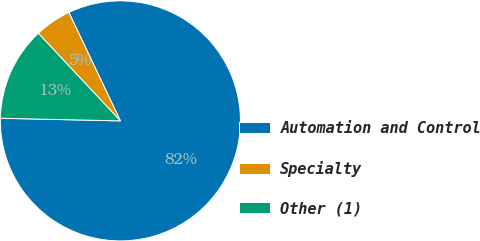<chart> <loc_0><loc_0><loc_500><loc_500><pie_chart><fcel>Automation and Control<fcel>Specialty<fcel>Other (1)<nl><fcel>82.4%<fcel>4.92%<fcel>12.67%<nl></chart> 